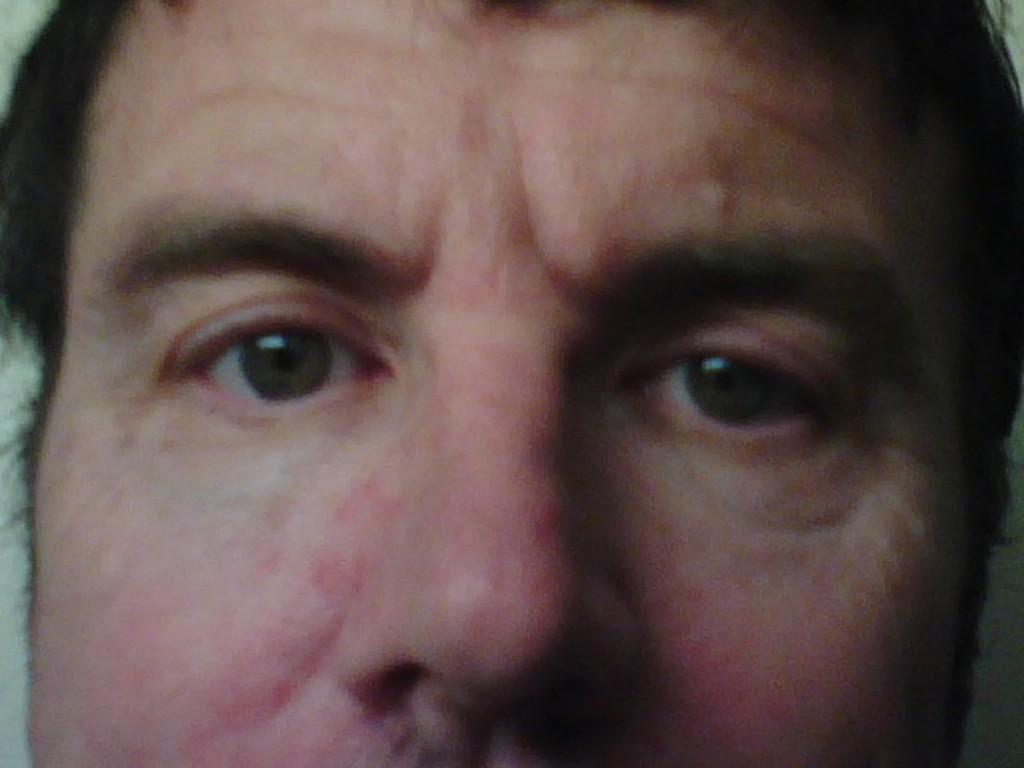What is the main subject of the image? There is a person's face in the image. How many fingers can be seen on the person's hand in the image? There is no hand or fingers visible in the image; only the person's face is present. 